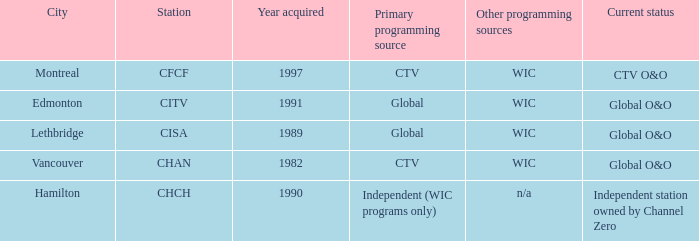How any were gained as the chan 1.0. 